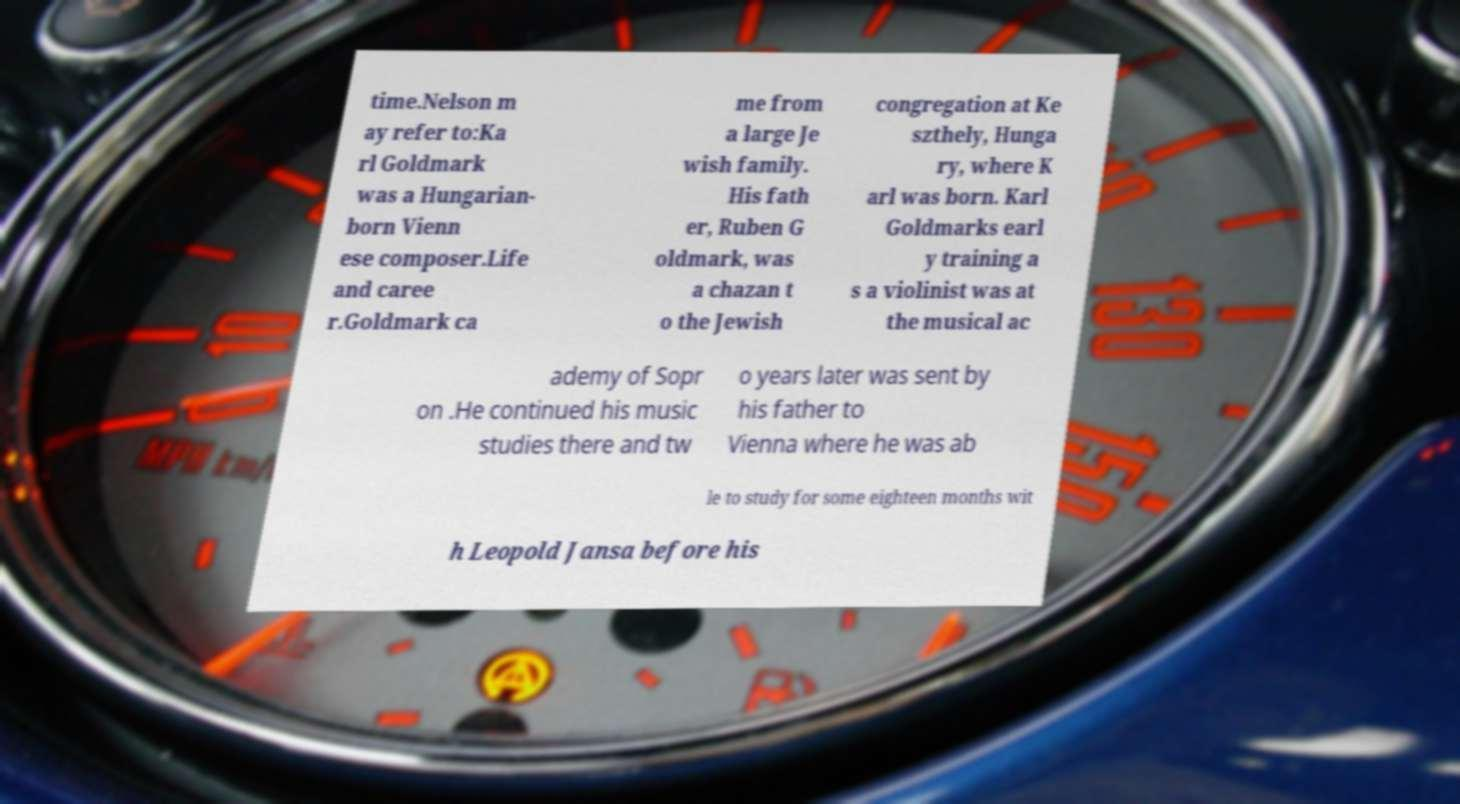For documentation purposes, I need the text within this image transcribed. Could you provide that? time.Nelson m ay refer to:Ka rl Goldmark was a Hungarian- born Vienn ese composer.Life and caree r.Goldmark ca me from a large Je wish family. His fath er, Ruben G oldmark, was a chazan t o the Jewish congregation at Ke szthely, Hunga ry, where K arl was born. Karl Goldmarks earl y training a s a violinist was at the musical ac ademy of Sopr on .He continued his music studies there and tw o years later was sent by his father to Vienna where he was ab le to study for some eighteen months wit h Leopold Jansa before his 